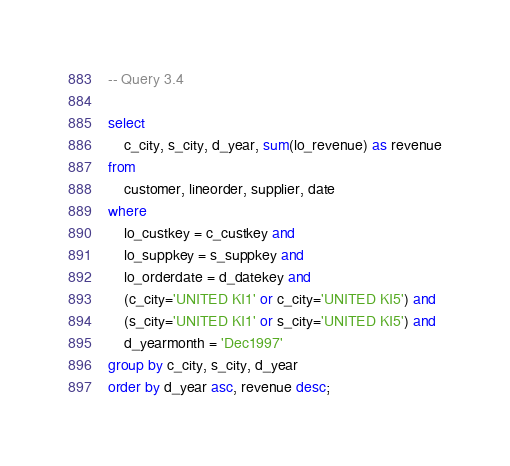<code> <loc_0><loc_0><loc_500><loc_500><_SQL_>-- Query 3.4

select
    c_city, s_city, d_year, sum(lo_revenue) as revenue
from
    customer, lineorder, supplier, date
where
    lo_custkey = c_custkey and
    lo_suppkey = s_suppkey and
    lo_orderdate = d_datekey and
    (c_city='UNITED KI1' or c_city='UNITED KI5') and
    (s_city='UNITED KI1' or s_city='UNITED KI5') and
    d_yearmonth = 'Dec1997'
group by c_city, s_city, d_year
order by d_year asc, revenue desc;
</code> 